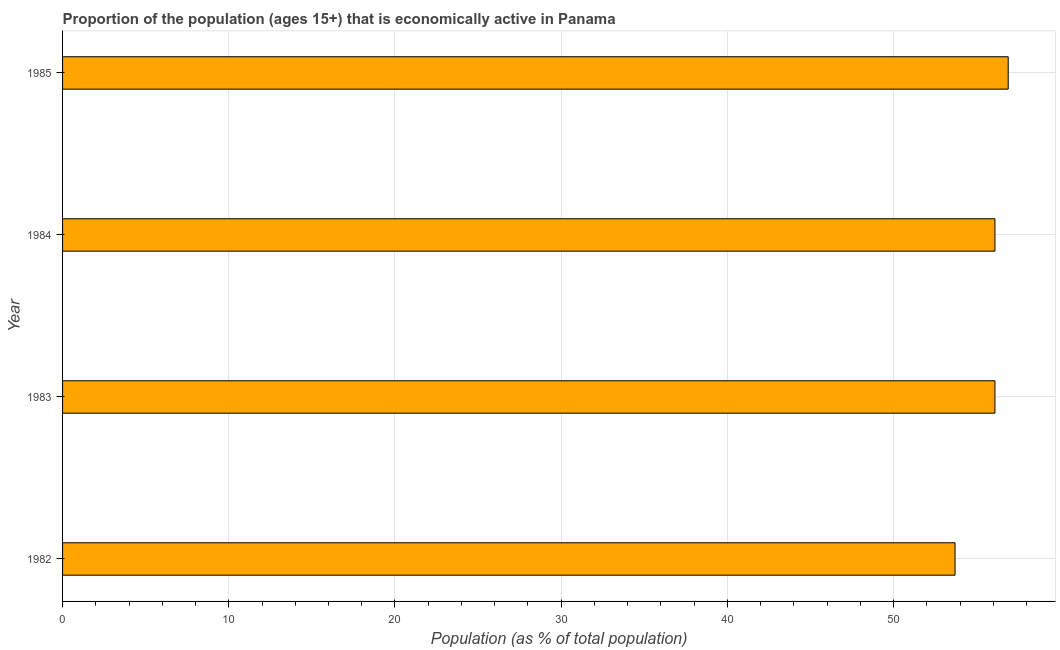Does the graph contain any zero values?
Give a very brief answer. No. What is the title of the graph?
Make the answer very short. Proportion of the population (ages 15+) that is economically active in Panama. What is the label or title of the X-axis?
Keep it short and to the point. Population (as % of total population). What is the percentage of economically active population in 1984?
Your response must be concise. 56.1. Across all years, what is the maximum percentage of economically active population?
Keep it short and to the point. 56.9. Across all years, what is the minimum percentage of economically active population?
Provide a short and direct response. 53.7. In which year was the percentage of economically active population maximum?
Give a very brief answer. 1985. In which year was the percentage of economically active population minimum?
Offer a terse response. 1982. What is the sum of the percentage of economically active population?
Your answer should be compact. 222.8. What is the average percentage of economically active population per year?
Provide a succinct answer. 55.7. What is the median percentage of economically active population?
Offer a very short reply. 56.1. What is the ratio of the percentage of economically active population in 1983 to that in 1984?
Offer a very short reply. 1. Is the difference between the percentage of economically active population in 1984 and 1985 greater than the difference between any two years?
Offer a terse response. No. What is the difference between the highest and the second highest percentage of economically active population?
Your answer should be compact. 0.8. What is the difference between the highest and the lowest percentage of economically active population?
Make the answer very short. 3.2. In how many years, is the percentage of economically active population greater than the average percentage of economically active population taken over all years?
Offer a very short reply. 3. What is the Population (as % of total population) of 1982?
Make the answer very short. 53.7. What is the Population (as % of total population) in 1983?
Provide a succinct answer. 56.1. What is the Population (as % of total population) in 1984?
Your answer should be compact. 56.1. What is the Population (as % of total population) in 1985?
Keep it short and to the point. 56.9. What is the difference between the Population (as % of total population) in 1982 and 1983?
Offer a very short reply. -2.4. What is the difference between the Population (as % of total population) in 1982 and 1984?
Give a very brief answer. -2.4. What is the difference between the Population (as % of total population) in 1983 and 1984?
Ensure brevity in your answer.  0. What is the difference between the Population (as % of total population) in 1983 and 1985?
Give a very brief answer. -0.8. What is the difference between the Population (as % of total population) in 1984 and 1985?
Your answer should be very brief. -0.8. What is the ratio of the Population (as % of total population) in 1982 to that in 1985?
Provide a short and direct response. 0.94. What is the ratio of the Population (as % of total population) in 1983 to that in 1984?
Keep it short and to the point. 1. 